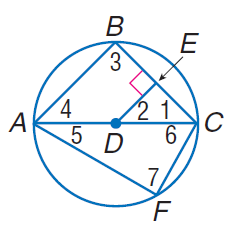Question: In \odot D, D E \cong E C, m \widehat C F = 60, and D E \perp E C. Find m \widehat A F.
Choices:
A. 30
B. 60
C. 90
D. 120
Answer with the letter. Answer: D Question: In \odot D, D E \cong E C, m \widehat C F = 60, and D E \perp E C. Find m \angle 5.
Choices:
A. 30
B. 30
C. 60
D. 90
Answer with the letter. Answer: A Question: In \odot D, D E \cong E C, m C F = 60, and D E \perp E C. Find m \angle 4.
Choices:
A. 30
B. 45
C. 60
D. 90
Answer with the letter. Answer: B 